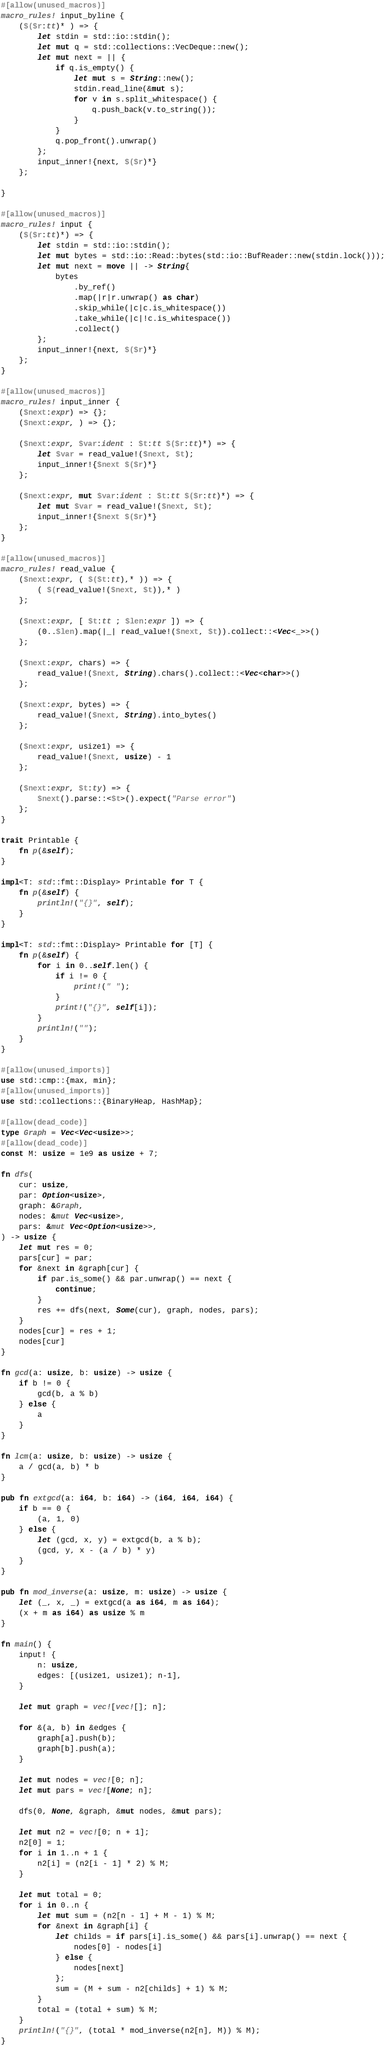<code> <loc_0><loc_0><loc_500><loc_500><_Rust_>#[allow(unused_macros)]
macro_rules! input_byline {
    ($($r:tt)* ) => {
        let stdin = std::io::stdin();
        let mut q = std::collections::VecDeque::new();
        let mut next = || {
            if q.is_empty() {
                let mut s = String::new();
                stdin.read_line(&mut s);
                for v in s.split_whitespace() {
                    q.push_back(v.to_string());
                }
            }
            q.pop_front().unwrap()
        };
        input_inner!{next, $($r)*}
    };

}

#[allow(unused_macros)]
macro_rules! input {
    ($($r:tt)*) => {
        let stdin = std::io::stdin();
        let mut bytes = std::io::Read::bytes(std::io::BufReader::new(stdin.lock()));
        let mut next = move || -> String{
            bytes
                .by_ref()
                .map(|r|r.unwrap() as char)
                .skip_while(|c|c.is_whitespace())
                .take_while(|c|!c.is_whitespace())
                .collect()
        };
        input_inner!{next, $($r)*}
    };
}

#[allow(unused_macros)]
macro_rules! input_inner {
    ($next:expr) => {};
    ($next:expr, ) => {};

    ($next:expr, $var:ident : $t:tt $($r:tt)*) => {
        let $var = read_value!($next, $t);
        input_inner!{$next $($r)*}
    };

    ($next:expr, mut $var:ident : $t:tt $($r:tt)*) => {
        let mut $var = read_value!($next, $t);
        input_inner!{$next $($r)*}
    };
}

#[allow(unused_macros)]
macro_rules! read_value {
    ($next:expr, ( $($t:tt),* )) => {
        ( $(read_value!($next, $t)),* )
    };

    ($next:expr, [ $t:tt ; $len:expr ]) => {
        (0..$len).map(|_| read_value!($next, $t)).collect::<Vec<_>>()
    };

    ($next:expr, chars) => {
        read_value!($next, String).chars().collect::<Vec<char>>()
    };

    ($next:expr, bytes) => {
        read_value!($next, String).into_bytes()
    };

    ($next:expr, usize1) => {
        read_value!($next, usize) - 1
    };

    ($next:expr, $t:ty) => {
        $next().parse::<$t>().expect("Parse error")
    };
}

trait Printable {
    fn p(&self);
}

impl<T: std::fmt::Display> Printable for T {
    fn p(&self) {
        println!("{}", self);
    }
}

impl<T: std::fmt::Display> Printable for [T] {
    fn p(&self) {
        for i in 0..self.len() {
            if i != 0 {
                print!(" ");
            }
            print!("{}", self[i]);
        }
        println!("");
    }
}

#[allow(unused_imports)]
use std::cmp::{max, min};
#[allow(unused_imports)]
use std::collections::{BinaryHeap, HashMap};

#[allow(dead_code)]
type Graph = Vec<Vec<usize>>;
#[allow(dead_code)]
const M: usize = 1e9 as usize + 7;

fn dfs(
    cur: usize,
    par: Option<usize>,
    graph: &Graph,
    nodes: &mut Vec<usize>,
    pars: &mut Vec<Option<usize>>,
) -> usize {
    let mut res = 0;
    pars[cur] = par;
    for &next in &graph[cur] {
        if par.is_some() && par.unwrap() == next {
            continue;
        }
        res += dfs(next, Some(cur), graph, nodes, pars);
    }
    nodes[cur] = res + 1;
    nodes[cur]
}

fn gcd(a: usize, b: usize) -> usize {
    if b != 0 {
        gcd(b, a % b)
    } else {
        a
    }
}

fn lcm(a: usize, b: usize) -> usize {
    a / gcd(a, b) * b
}

pub fn extgcd(a: i64, b: i64) -> (i64, i64, i64) {
    if b == 0 {
        (a, 1, 0)
    } else {
        let (gcd, x, y) = extgcd(b, a % b);
        (gcd, y, x - (a / b) * y)
    }
}

pub fn mod_inverse(a: usize, m: usize) -> usize {
    let (_, x, _) = extgcd(a as i64, m as i64);
    (x + m as i64) as usize % m
}

fn main() {
    input! {
        n: usize,
        edges: [(usize1, usize1); n-1],
    }

    let mut graph = vec![vec![]; n];

    for &(a, b) in &edges {
        graph[a].push(b);
        graph[b].push(a);
    }

    let mut nodes = vec![0; n];
    let mut pars = vec![None; n];

    dfs(0, None, &graph, &mut nodes, &mut pars);

    let mut n2 = vec![0; n + 1];
    n2[0] = 1;
    for i in 1..n + 1 {
        n2[i] = (n2[i - 1] * 2) % M;
    }

    let mut total = 0;
    for i in 0..n {
        let mut sum = (n2[n - 1] + M - 1) % M;
        for &next in &graph[i] {
            let childs = if pars[i].is_some() && pars[i].unwrap() == next {
                nodes[0] - nodes[i]
            } else {
                nodes[next]
            };
            sum = (M + sum - n2[childs] + 1) % M;
        }
        total = (total + sum) % M;
    }
    println!("{}", (total * mod_inverse(n2[n], M)) % M);
}
</code> 